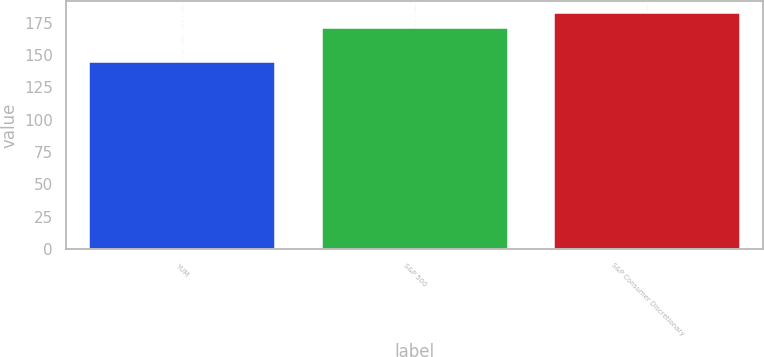Convert chart to OTSL. <chart><loc_0><loc_0><loc_500><loc_500><bar_chart><fcel>YUM<fcel>S&P 500<fcel>S&P Consumer Discretionary<nl><fcel>145<fcel>171<fcel>183<nl></chart> 